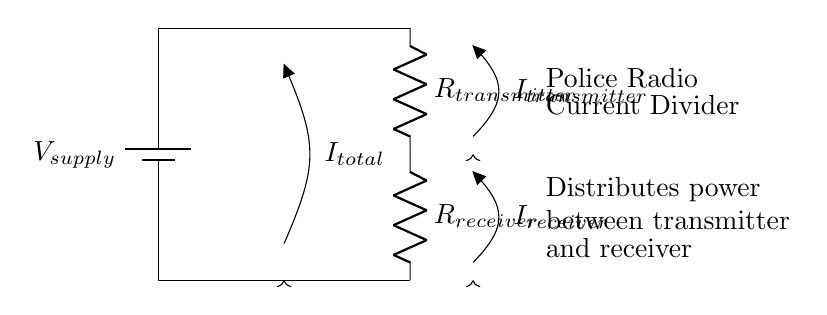What is the source voltage in this circuit? The given circuit shows a battery labeled V_supply, which represents the source voltage supplying the circuit.
Answer: V_supply What type of circuit is depicted here? The circuit diagram illustrates a current divider specifically designed to distribute current between two loads, which are the transmitter and receiver.
Answer: Current divider What resistances are present in the circuit? The circuit contains two resistors, labeled R_transmitter and R_receiver, which indicate the resistance values for the transmitter and receiver respectively.
Answer: R_transmitter, R_receiver What is the total current flowing in the circuit? In the diagram, the total current is indicated by the arrow labeled I_total, which flows from the battery through the circuit components.
Answer: I_total How is the current divided between the transmitter and receiver? The current division occurs based on the resistance values; the greater the resistance, the lesser the current through that branch, following the current divider rule.
Answer: Based on resistances What current flows through the transmitter? The current flowing through the transmitter is labeled I_transmitter, which is the portion of the total current allocated to the transmitter in the current divider arrangement.
Answer: I_transmitter What current flows through the receiver? The circuit indicates that the current flowing through the receiver is labeled I_receiver, representing the portion of the total current allocated to the receiver.
Answer: I_receiver 